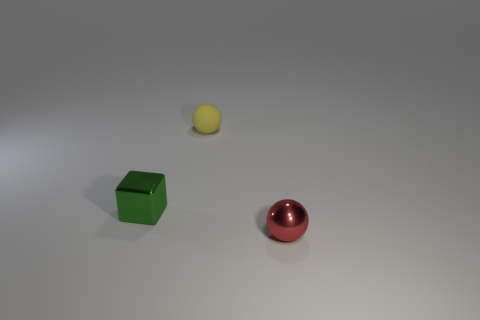Add 2 red shiny spheres. How many objects exist? 5 Subtract all balls. How many objects are left? 1 Subtract all big red matte cylinders. Subtract all red objects. How many objects are left? 2 Add 2 small things. How many small things are left? 5 Add 3 small red balls. How many small red balls exist? 4 Subtract 1 green blocks. How many objects are left? 2 